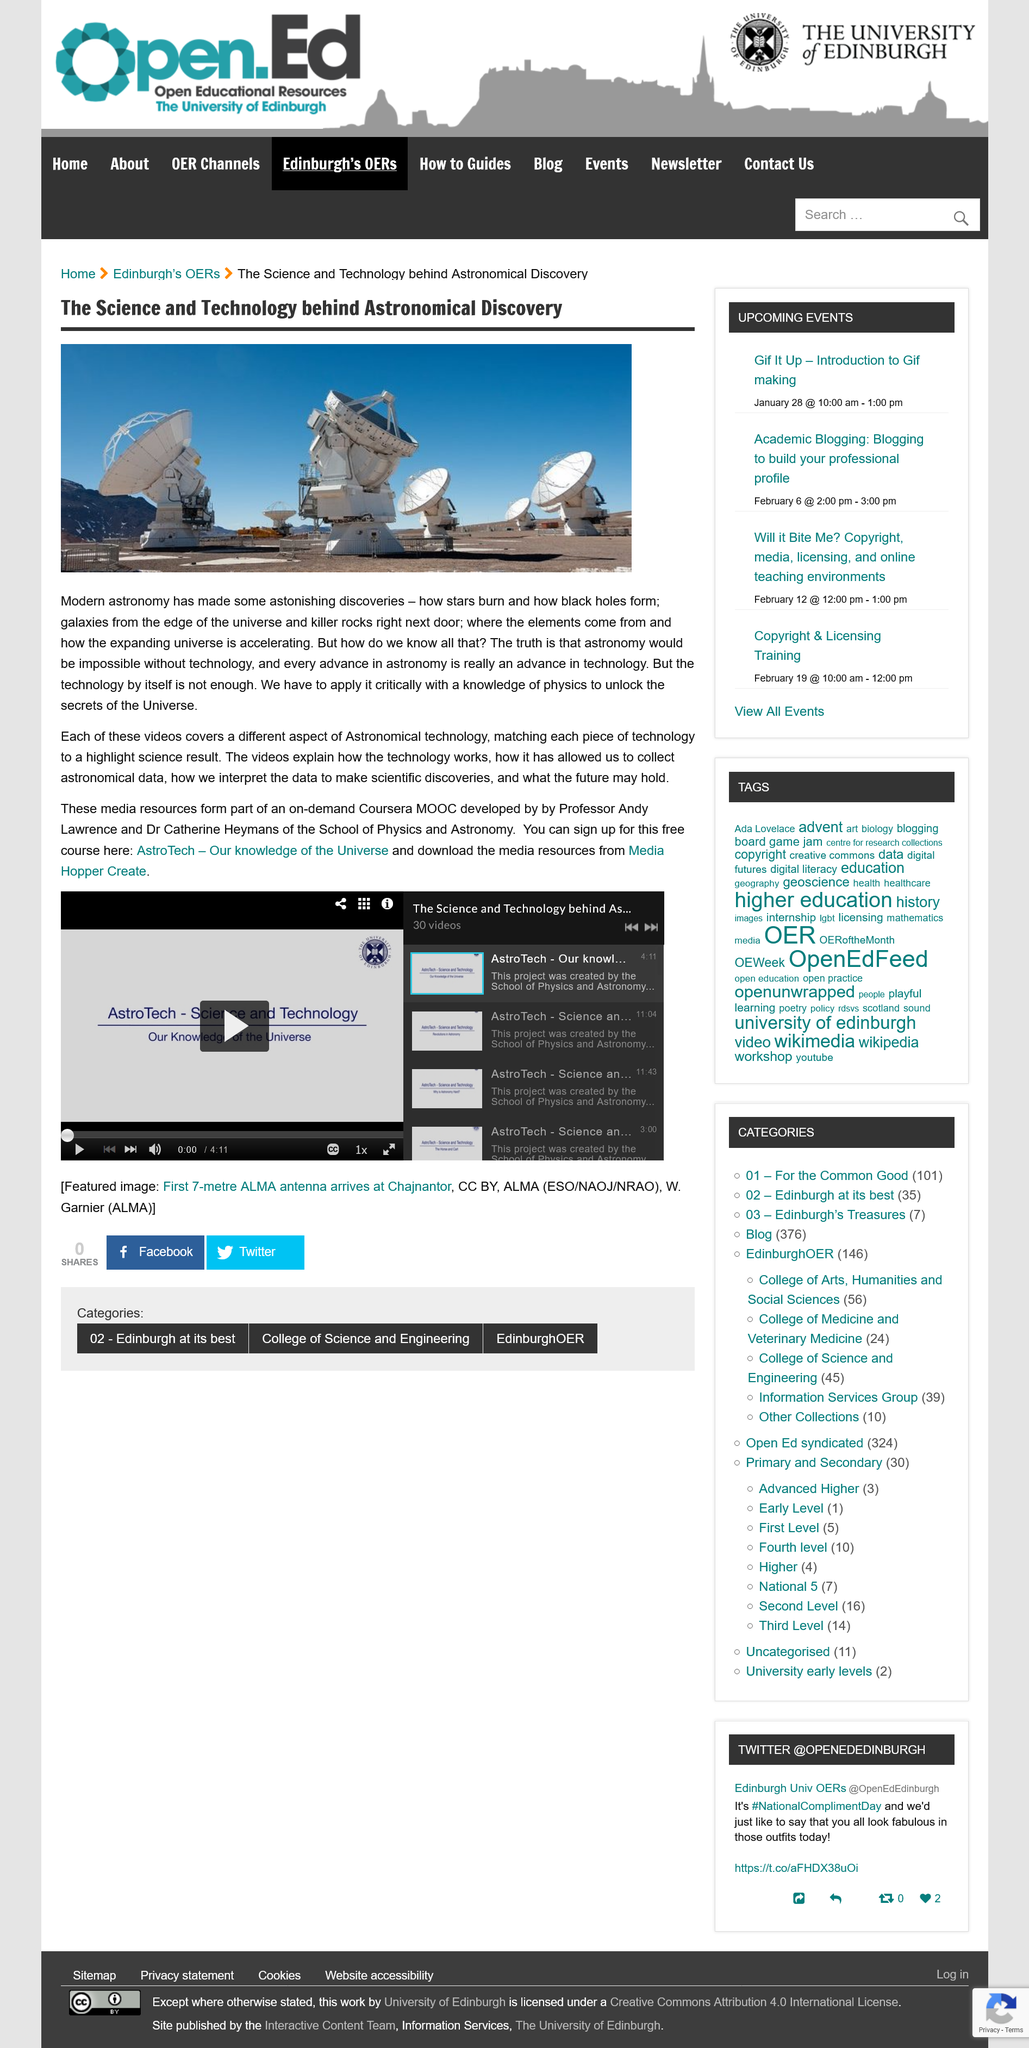Draw attention to some important aspects in this diagram. Andy Lawrence is a professor who holds a position. The videos are part of a MOOC (Massive Open Online Course) offered on Coursera, which is an on-demand course. Catherine Heymans is a member of The School of Physics and Astronomy. 